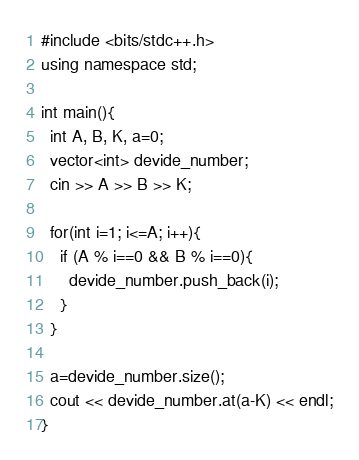Convert code to text. <code><loc_0><loc_0><loc_500><loc_500><_C++_>#include <bits/stdc++.h>
using namespace std;

int main(){
  int A, B, K, a=0;
  vector<int> devide_number;
  cin >> A >> B >> K;
  
  for(int i=1; i<=A; i++){
    if (A % i==0 && B % i==0){
      devide_number.push_back(i);
    }
  }
  
  a=devide_number.size();
  cout << devide_number.at(a-K) << endl;
}
</code> 